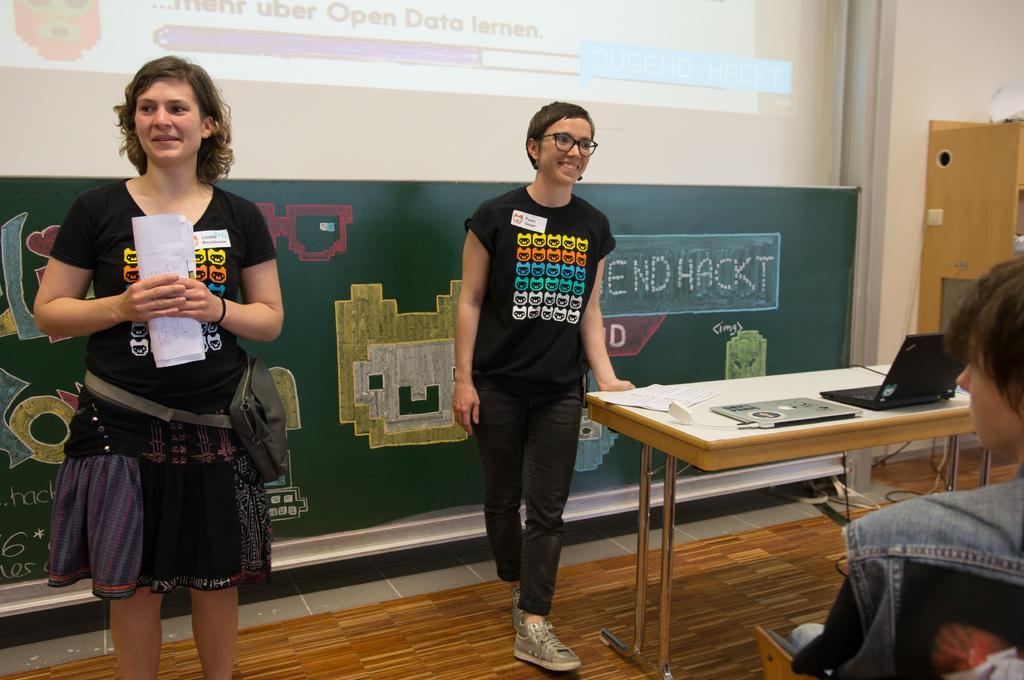How would you summarize this image in a sentence or two? In this image I can see two women are standing and also I can see one is holding a paper and another one is wearing a specs. I can see smile on their faces. Here I can see a table and a laptop on it. I can also see one more person over here. 